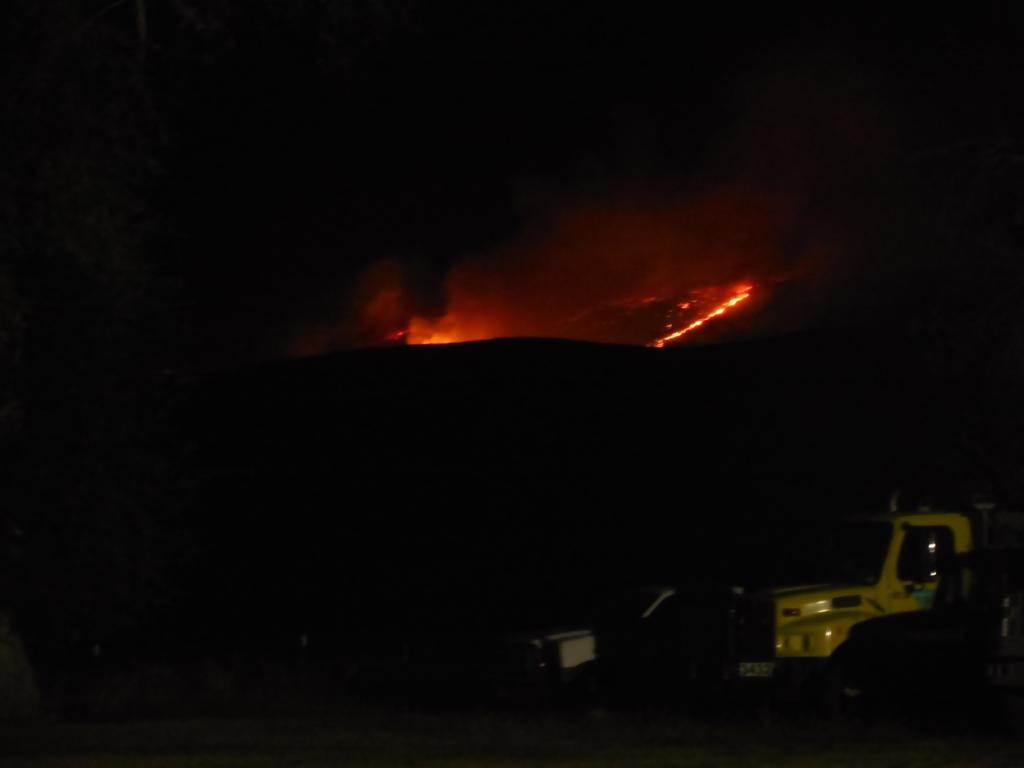What time of day was the image taken? The image was taken during night time. What can be seen in the image besides the night sky? There is a vehicle and a fire in the background of the image. What type of cast is visible on the vehicle in the image? There is no cast visible on the vehicle in the image. What type of match is being used to light the fire in the background? There is no match present in the image; the fire is already burning. 